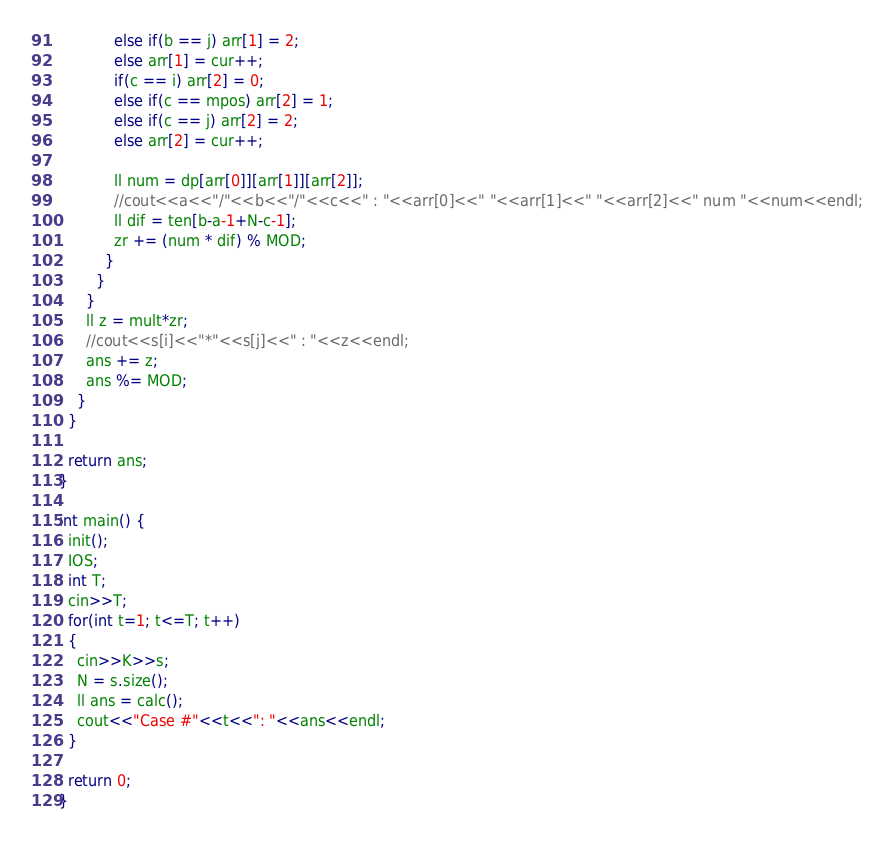Convert code to text. <code><loc_0><loc_0><loc_500><loc_500><_C++_>            else if(b == j) arr[1] = 2;
            else arr[1] = cur++;
            if(c == i) arr[2] = 0;
            else if(c == mpos) arr[2] = 1;
            else if(c == j) arr[2] = 2;
            else arr[2] = cur++;

            ll num = dp[arr[0]][arr[1]][arr[2]];
            //cout<<a<<"/"<<b<<"/"<<c<<" : "<<arr[0]<<" "<<arr[1]<<" "<<arr[2]<<" num "<<num<<endl;
            ll dif = ten[b-a-1+N-c-1];
            zr += (num * dif) % MOD;
          }
        }
      }
      ll z = mult*zr;
      //cout<<s[i]<<"*"<<s[j]<<" : "<<z<<endl;
      ans += z;
      ans %= MOD;
    }
  }

  return ans;
}

int main() {
  init();
  IOS;
  int T;
  cin>>T;
  for(int t=1; t<=T; t++)
  {
    cin>>K>>s;
    N = s.size();
    ll ans = calc();
    cout<<"Case #"<<t<<": "<<ans<<endl;
  }

  return 0;
}
</code> 